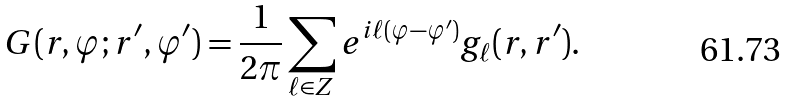<formula> <loc_0><loc_0><loc_500><loc_500>G ( r , \varphi ; r ^ { \prime } , \varphi ^ { \prime } ) = \frac { 1 } { 2 \pi } \sum _ { \ell \in Z } e ^ { i \ell ( \varphi - \varphi ^ { \prime } ) } g _ { \ell } ( r , r ^ { \prime } ) .</formula> 